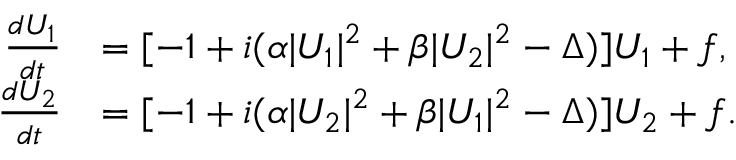Convert formula to latex. <formula><loc_0><loc_0><loc_500><loc_500>\begin{array} { r l } { \frac { d U _ { 1 } } { d t } } & { = [ - 1 + i ( \alpha | U _ { 1 } | ^ { 2 } + \beta | U _ { 2 } | ^ { 2 } - \Delta ) ] U _ { 1 } + f , } \\ { \frac { d U _ { 2 } } { d t } } & { = [ - 1 + i ( \alpha | U _ { 2 } | ^ { 2 } + \beta | U _ { 1 } | ^ { 2 } - \Delta ) ] U _ { 2 } + f . } \end{array}</formula> 